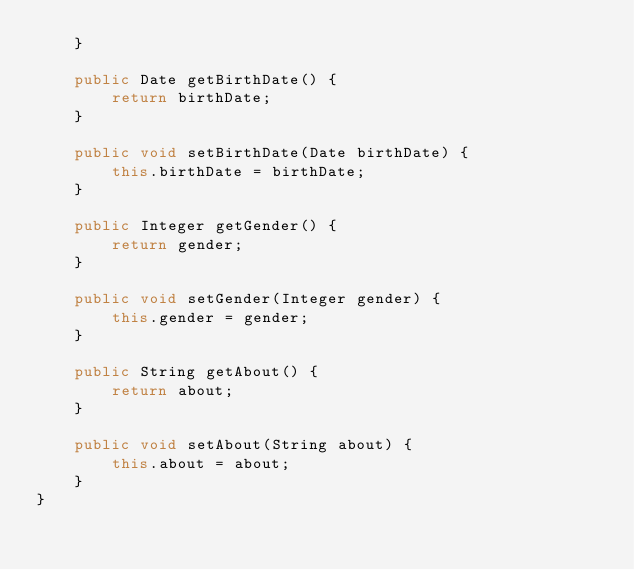Convert code to text. <code><loc_0><loc_0><loc_500><loc_500><_Java_>    }

    public Date getBirthDate() {
        return birthDate;
    }

    public void setBirthDate(Date birthDate) {
        this.birthDate = birthDate;
    }

    public Integer getGender() {
        return gender;
    }

    public void setGender(Integer gender) {
        this.gender = gender;
    }

    public String getAbout() {
        return about;
    }

    public void setAbout(String about) {
        this.about = about;
    }
}
</code> 